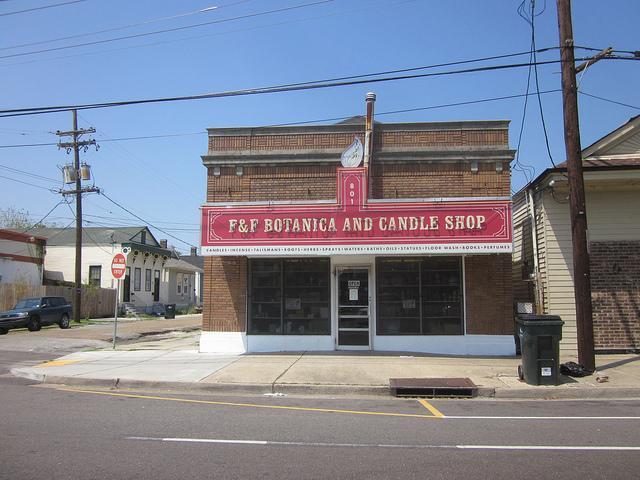How many people are wearing a red helmet?
Give a very brief answer. 0. 